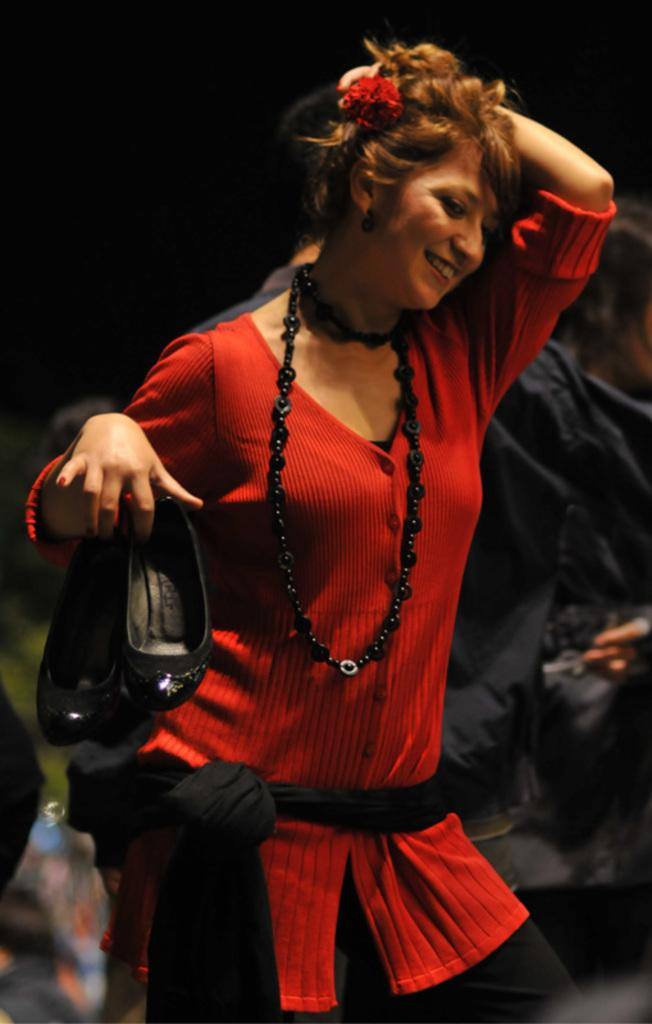Who is the main subject in the foreground of the picture? There is a woman in the foreground of the picture. What is the woman wearing? The woman is wearing a red dress. What is the woman holding in the picture? The woman is holding shoes. What can be seen in the middle of the image? There are people in the middle of the image. How would you describe the background of the image? The background of the image is blurred. What type of property does the woman's father own in the image? There is no information about the woman's father or any property in the image. 